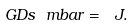Convert formula to latex. <formula><loc_0><loc_0><loc_500><loc_500>\ G D s \ m b a r = \ J .</formula> 